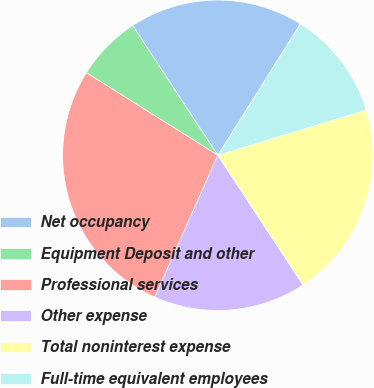<chart> <loc_0><loc_0><loc_500><loc_500><pie_chart><fcel>Net occupancy<fcel>Equipment Deposit and other<fcel>Professional services<fcel>Other expense<fcel>Total noninterest expense<fcel>Full-time equivalent employees<nl><fcel>18.18%<fcel>6.82%<fcel>27.27%<fcel>15.91%<fcel>20.45%<fcel>11.36%<nl></chart> 